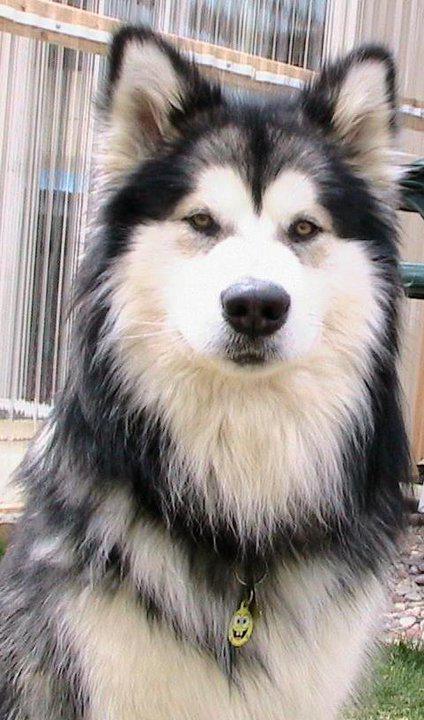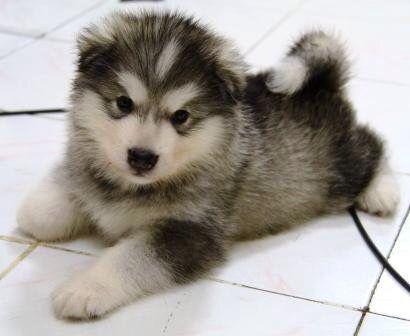The first image is the image on the left, the second image is the image on the right. Analyze the images presented: Is the assertion "The puppy on the left has its tongue visible." valid? Answer yes or no. No. The first image is the image on the left, the second image is the image on the right. Analyze the images presented: Is the assertion "One of the two malamutes has its tongue sticking out, while the other is just staring at the camera." valid? Answer yes or no. No. 